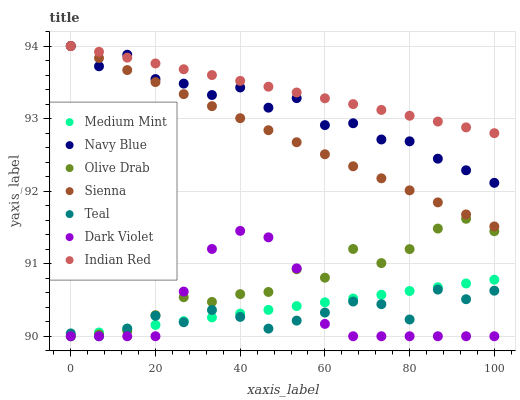Does Teal have the minimum area under the curve?
Answer yes or no. Yes. Does Indian Red have the maximum area under the curve?
Answer yes or no. Yes. Does Navy Blue have the minimum area under the curve?
Answer yes or no. No. Does Navy Blue have the maximum area under the curve?
Answer yes or no. No. Is Medium Mint the smoothest?
Answer yes or no. Yes. Is Navy Blue the roughest?
Answer yes or no. Yes. Is Indian Red the smoothest?
Answer yes or no. No. Is Indian Red the roughest?
Answer yes or no. No. Does Medium Mint have the lowest value?
Answer yes or no. Yes. Does Navy Blue have the lowest value?
Answer yes or no. No. Does Sienna have the highest value?
Answer yes or no. Yes. Does Dark Violet have the highest value?
Answer yes or no. No. Is Olive Drab less than Navy Blue?
Answer yes or no. Yes. Is Indian Red greater than Dark Violet?
Answer yes or no. Yes. Does Navy Blue intersect Sienna?
Answer yes or no. Yes. Is Navy Blue less than Sienna?
Answer yes or no. No. Is Navy Blue greater than Sienna?
Answer yes or no. No. Does Olive Drab intersect Navy Blue?
Answer yes or no. No. 